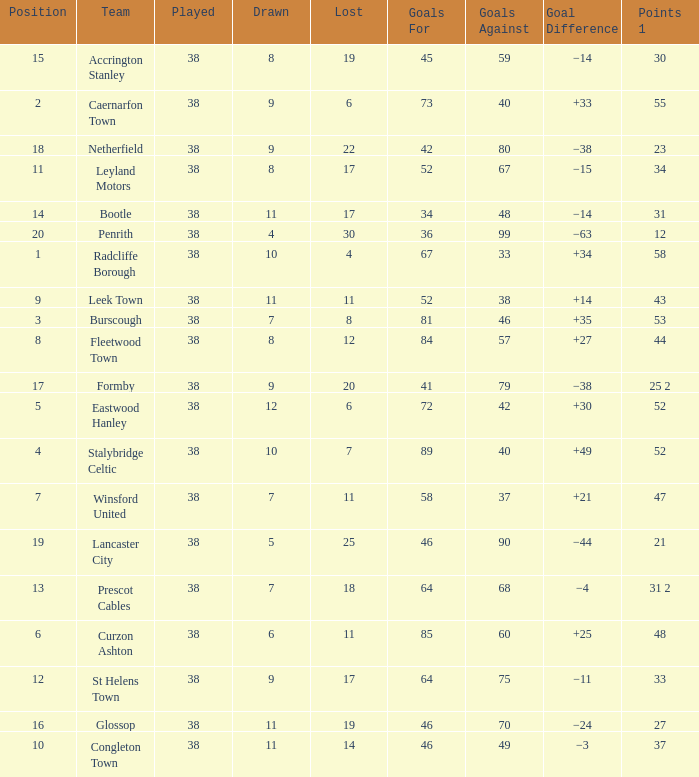Can you give me this table as a dict? {'header': ['Position', 'Team', 'Played', 'Drawn', 'Lost', 'Goals For', 'Goals Against', 'Goal Difference', 'Points 1'], 'rows': [['15', 'Accrington Stanley', '38', '8', '19', '45', '59', '−14', '30'], ['2', 'Caernarfon Town', '38', '9', '6', '73', '40', '+33', '55'], ['18', 'Netherfield', '38', '9', '22', '42', '80', '−38', '23'], ['11', 'Leyland Motors', '38', '8', '17', '52', '67', '−15', '34'], ['14', 'Bootle', '38', '11', '17', '34', '48', '−14', '31'], ['20', 'Penrith', '38', '4', '30', '36', '99', '−63', '12'], ['1', 'Radcliffe Borough', '38', '10', '4', '67', '33', '+34', '58'], ['9', 'Leek Town', '38', '11', '11', '52', '38', '+14', '43'], ['3', 'Burscough', '38', '7', '8', '81', '46', '+35', '53'], ['8', 'Fleetwood Town', '38', '8', '12', '84', '57', '+27', '44'], ['17', 'Formby', '38', '9', '20', '41', '79', '−38', '25 2'], ['5', 'Eastwood Hanley', '38', '12', '6', '72', '42', '+30', '52'], ['4', 'Stalybridge Celtic', '38', '10', '7', '89', '40', '+49', '52'], ['7', 'Winsford United', '38', '7', '11', '58', '37', '+21', '47'], ['19', 'Lancaster City', '38', '5', '25', '46', '90', '−44', '21'], ['13', 'Prescot Cables', '38', '7', '18', '64', '68', '−4', '31 2'], ['6', 'Curzon Ashton', '38', '6', '11', '85', '60', '+25', '48'], ['12', 'St Helens Town', '38', '9', '17', '64', '75', '−11', '33'], ['16', 'Glossop', '38', '11', '19', '46', '70', '−24', '27'], ['10', 'Congleton Town', '38', '11', '14', '46', '49', '−3', '37']]} WHAT GOALS AGAINST HAD A GOAL FOR OF 46, AND PLAYED LESS THAN 38? None. 